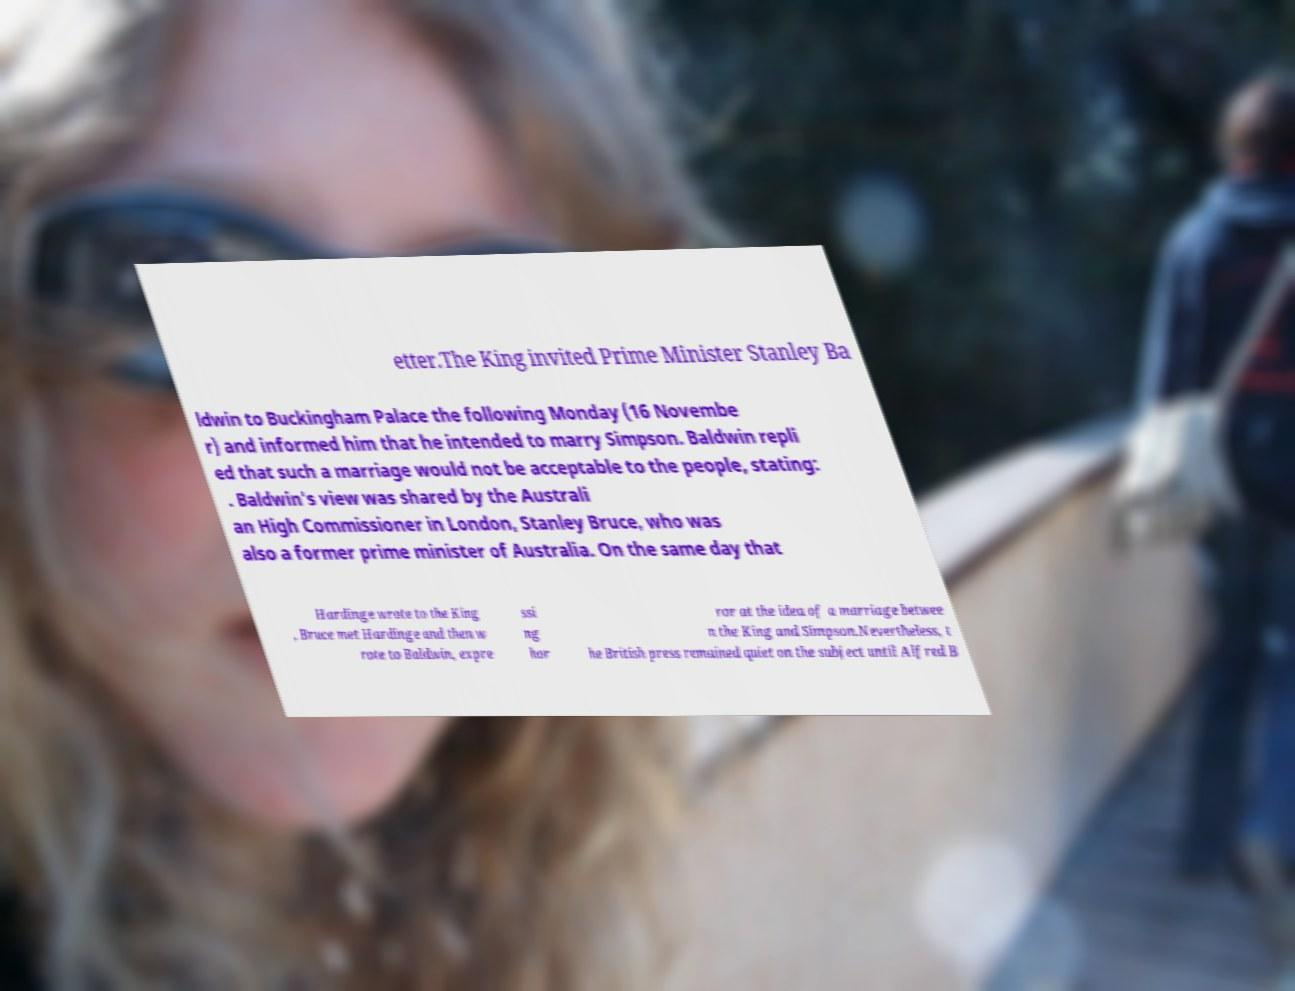What messages or text are displayed in this image? I need them in a readable, typed format. etter.The King invited Prime Minister Stanley Ba ldwin to Buckingham Palace the following Monday (16 Novembe r) and informed him that he intended to marry Simpson. Baldwin repli ed that such a marriage would not be acceptable to the people, stating: . Baldwin's view was shared by the Australi an High Commissioner in London, Stanley Bruce, who was also a former prime minister of Australia. On the same day that Hardinge wrote to the King , Bruce met Hardinge and then w rote to Baldwin, expre ssi ng hor ror at the idea of a marriage betwee n the King and Simpson.Nevertheless, t he British press remained quiet on the subject until Alfred B 